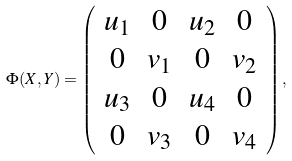<formula> <loc_0><loc_0><loc_500><loc_500>\Phi ( X , Y ) = \left ( \begin{array} { c c c c } u _ { 1 } & 0 & u _ { 2 } & 0 \\ 0 & v _ { 1 } & 0 & v _ { 2 } \\ u _ { 3 } & 0 & u _ { 4 } & 0 \\ 0 & v _ { 3 } & 0 & v _ { 4 } \\ \end{array} \right ) ,</formula> 